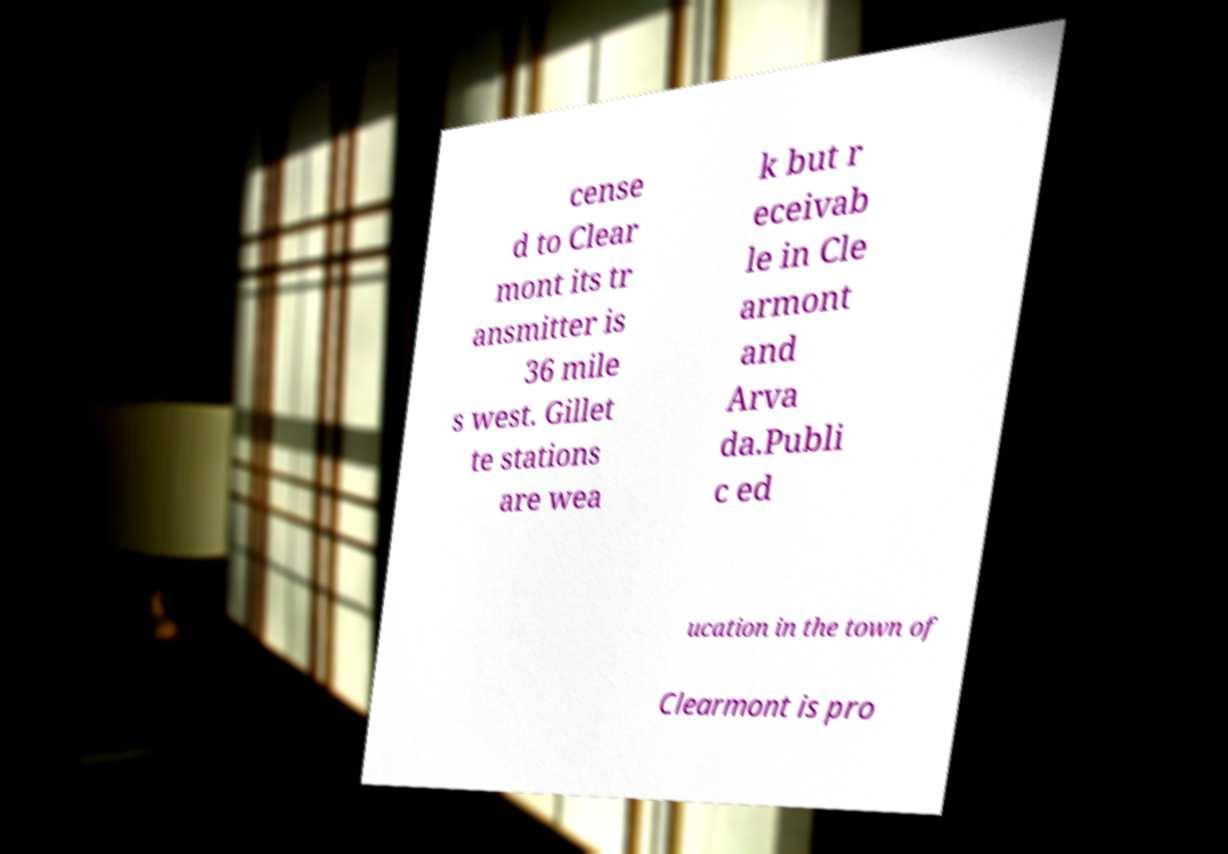For documentation purposes, I need the text within this image transcribed. Could you provide that? cense d to Clear mont its tr ansmitter is 36 mile s west. Gillet te stations are wea k but r eceivab le in Cle armont and Arva da.Publi c ed ucation in the town of Clearmont is pro 